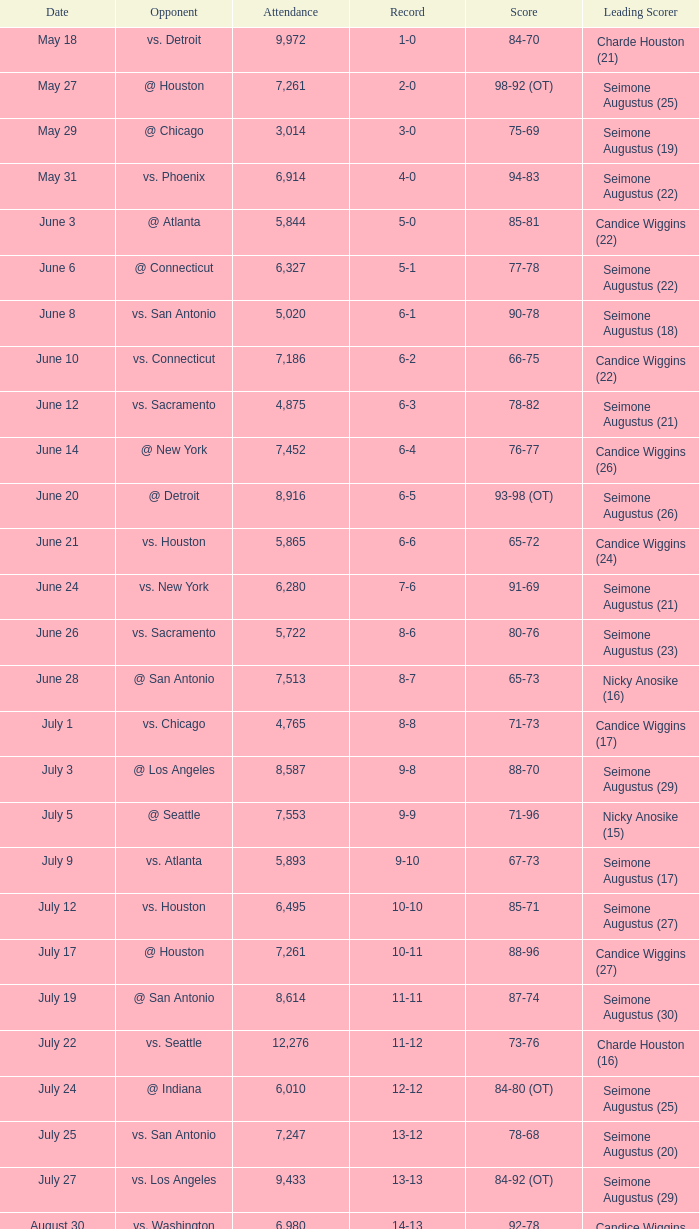Which Attendance has a Date of september 7? 7999.0. 